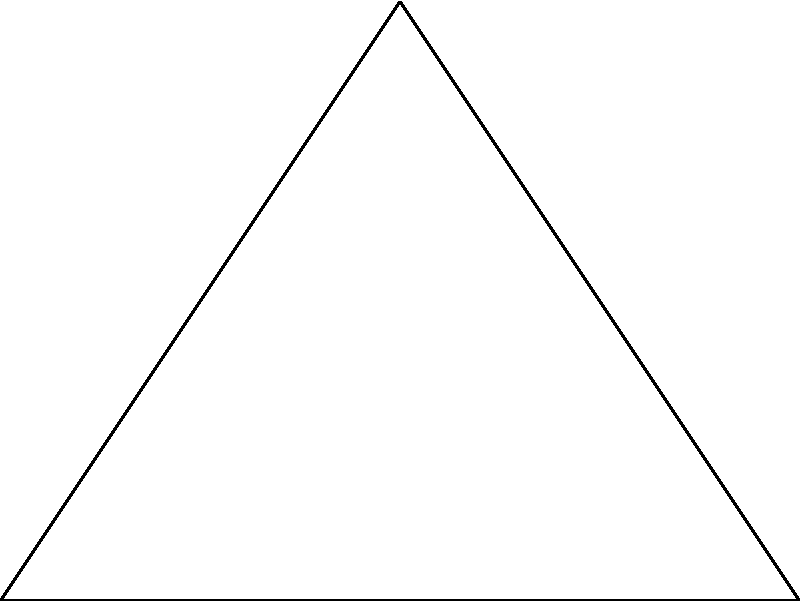In a triangular safety zone established after the JRC incident, three monitoring stations are placed at the vertices of the triangle. The distances between stations A and B, A and C, and B and C are 4 km, 3 km, and 3 km respectively. Each station has a circular coverage area with a radius of 1 km. What is the area of the region that is covered by at least two monitoring stations? To solve this problem, we need to follow these steps:

1) First, we need to find the area of intersection between each pair of circles:

   a) For circles A and B:
      The distance between centers is 4 km, which is greater than the sum of their radii (2 km). Therefore, these circles do not intersect.

   b) For circles A and C, and B and C:
      The distance between centers is 3 km, and the sum of radii is 2 km. We can use the formula for the area of intersection of two circles:

      $$A = 2r^2 \arccos(\frac{d}{2r}) - d\sqrt{r^2 - (\frac{d}{2})^2}$$

      where $r$ is the radius (1 km) and $d$ is the distance between centers (3 km).

      $$A = 2(1)^2 \arccos(\frac{3}{2(1)}) - 3\sqrt{1^2 - (\frac{3}{2})^2}$$
      $$A = 2 \arccos(1.5) - 3\sqrt{1 - 2.25}$$
      $$A = 2 \arccos(1.5) - 3\sqrt{-1.25}$$

      Since $\arccos(1.5)$ is undefined and we're trying to take the square root of a negative number, this means that these circles also do not intersect.

2) Since no two circles intersect, the area covered by at least two stations is 0.
Answer: 0 square kilometers 